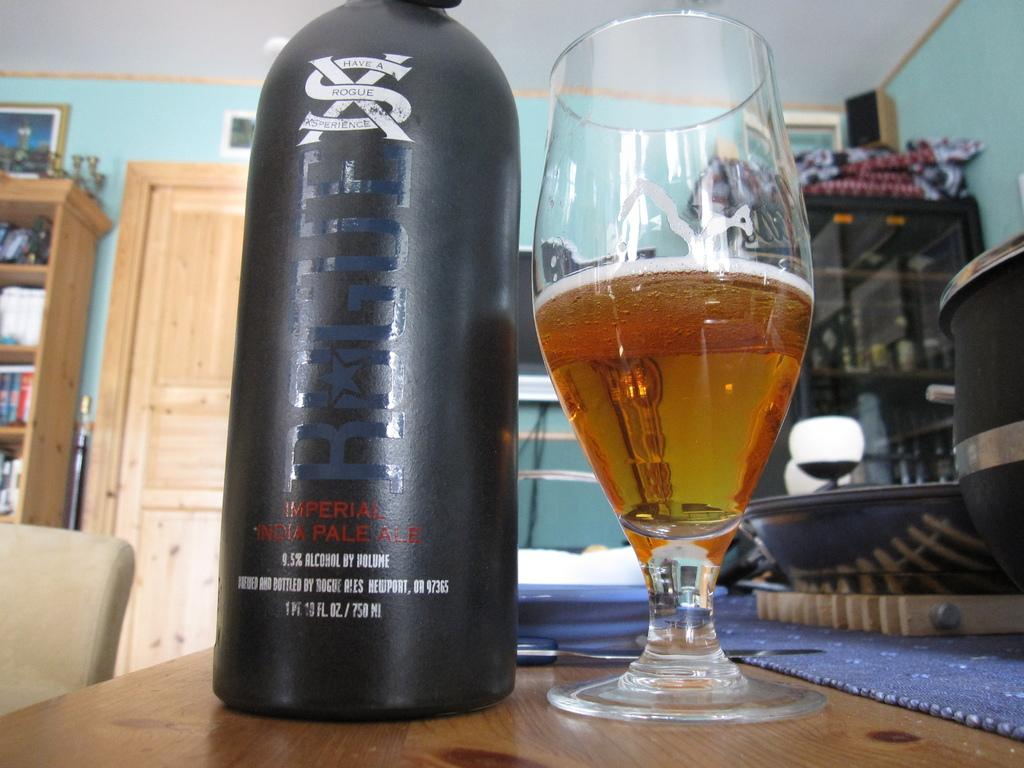<image>
Offer a succinct explanation of the picture presented. a bottle and glass of Rogue imperial pale ale 